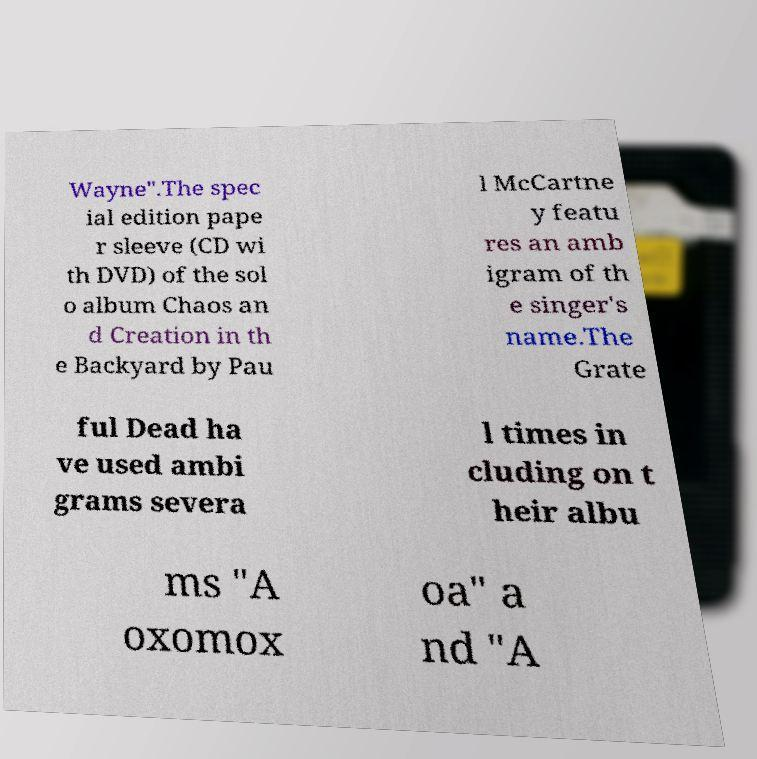I need the written content from this picture converted into text. Can you do that? Wayne".The spec ial edition pape r sleeve (CD wi th DVD) of the sol o album Chaos an d Creation in th e Backyard by Pau l McCartne y featu res an amb igram of th e singer's name.The Grate ful Dead ha ve used ambi grams severa l times in cluding on t heir albu ms "A oxomox oa" a nd "A 